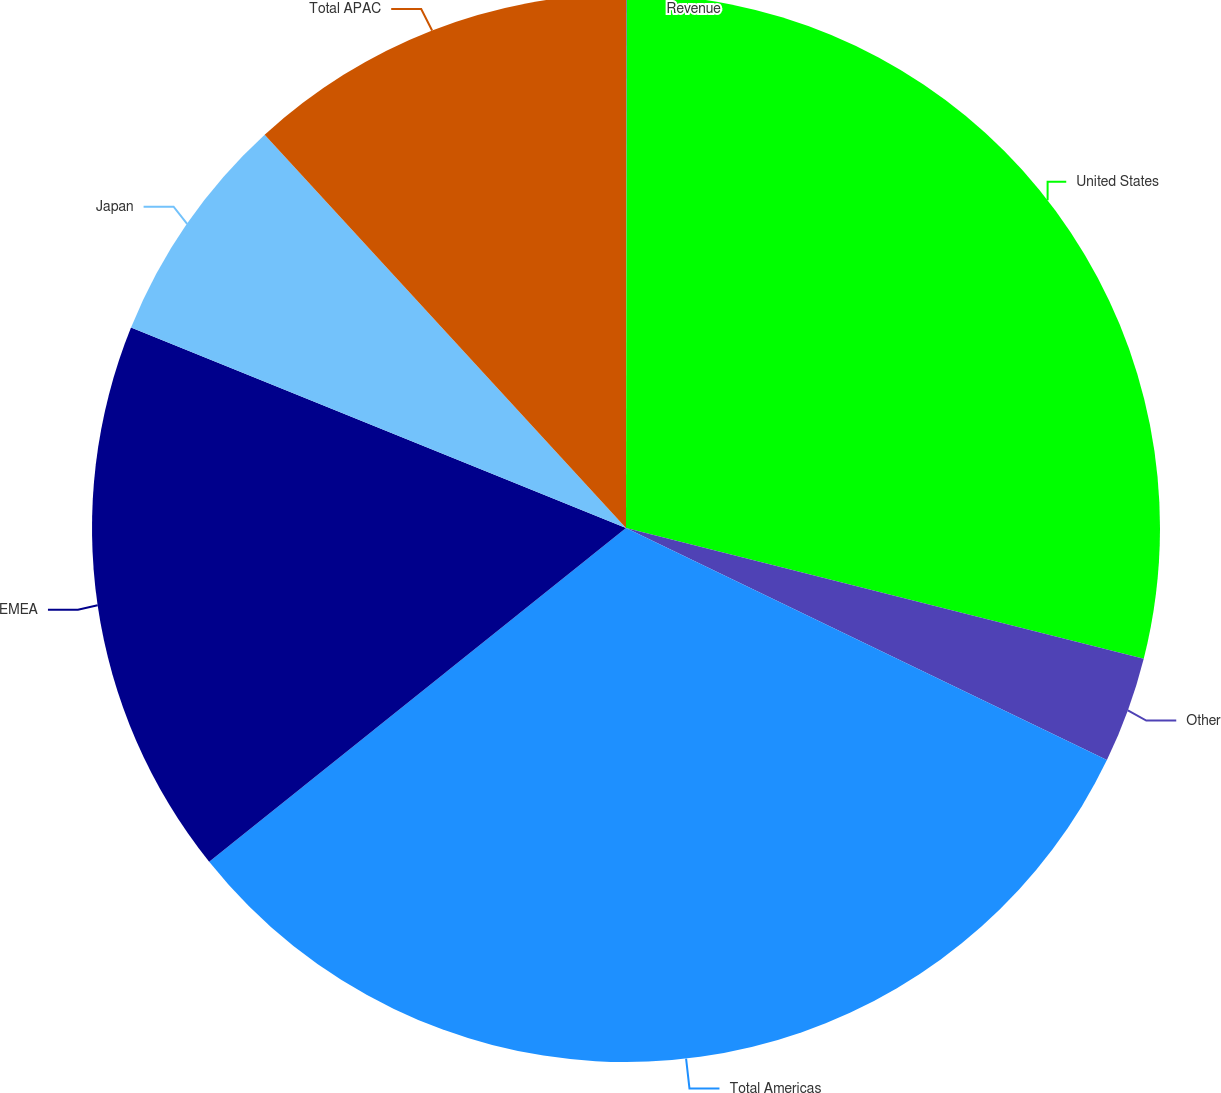Convert chart to OTSL. <chart><loc_0><loc_0><loc_500><loc_500><pie_chart><fcel>Revenue<fcel>United States<fcel>Other<fcel>Total Americas<fcel>EMEA<fcel>Japan<fcel>Total APAC<nl><fcel>0.03%<fcel>28.91%<fcel>3.22%<fcel>32.1%<fcel>16.87%<fcel>7.05%<fcel>11.83%<nl></chart> 